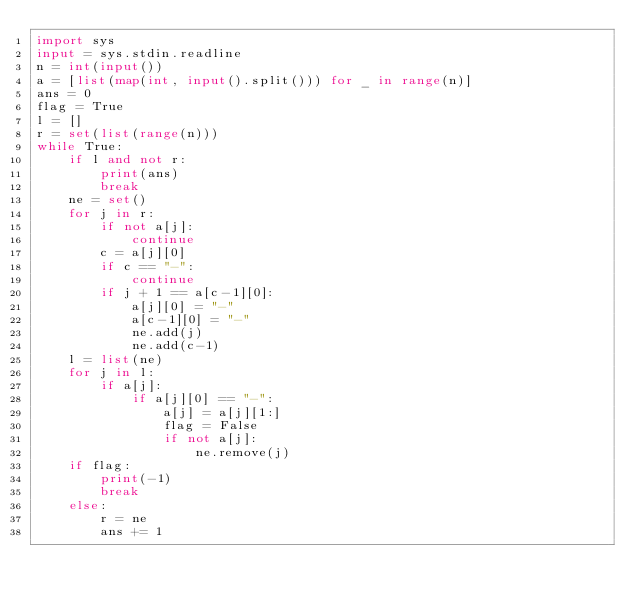Convert code to text. <code><loc_0><loc_0><loc_500><loc_500><_Python_>import sys
input = sys.stdin.readline
n = int(input())
a = [list(map(int, input().split())) for _ in range(n)]
ans = 0
flag = True
l = []
r = set(list(range(n)))
while True:
    if l and not r:
        print(ans)
        break
    ne = set()
    for j in r:
        if not a[j]:
            continue
        c = a[j][0]
        if c == "-":
            continue
        if j + 1 == a[c-1][0]:
            a[j][0] = "-"
            a[c-1][0] = "-"
            ne.add(j)
            ne.add(c-1)
    l = list(ne)
    for j in l:
        if a[j]:
            if a[j][0] == "-":
                a[j] = a[j][1:]
                flag = False
                if not a[j]:
                    ne.remove(j)
    if flag:
        print(-1)
        break
    else:
        r = ne
        ans += 1
</code> 